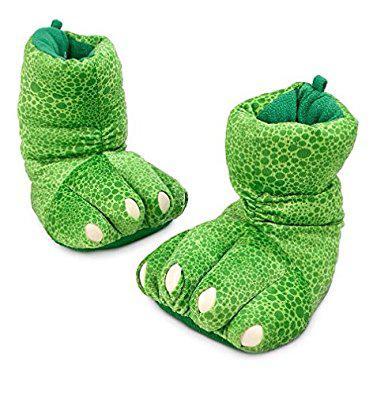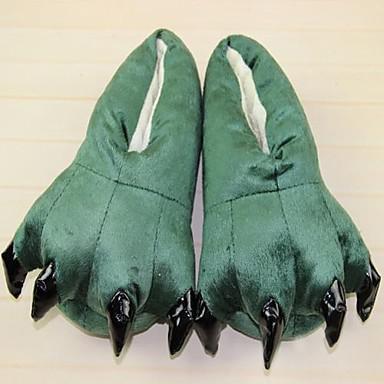The first image is the image on the left, the second image is the image on the right. For the images displayed, is the sentence "All slippers are solid colors and have four claws that project outward, but only the right image shows a matched pair of slippers." factually correct? Answer yes or no. No. The first image is the image on the left, the second image is the image on the right. For the images shown, is this caption "Three or more slippers in two or more colors resemble animal feet, with plastic toenails protruding from the end of each slipper." true? Answer yes or no. No. 